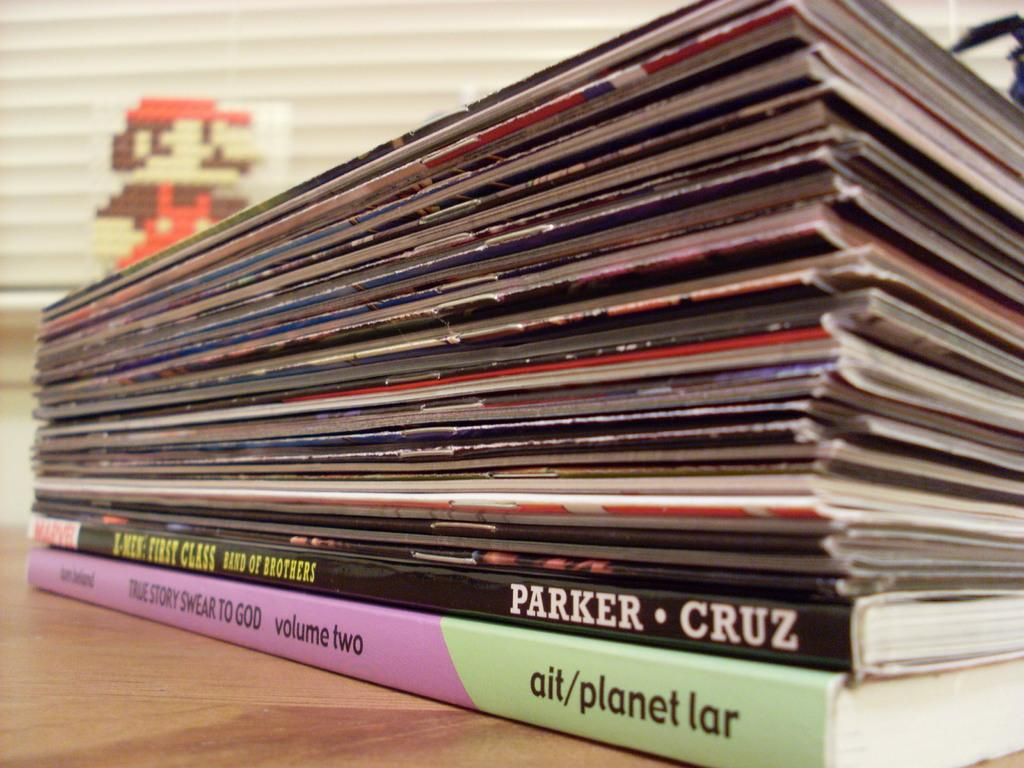<image>
Relay a brief, clear account of the picture shown. Black book in a stack of books with the authors names of Parker and Cruz written on the spine 